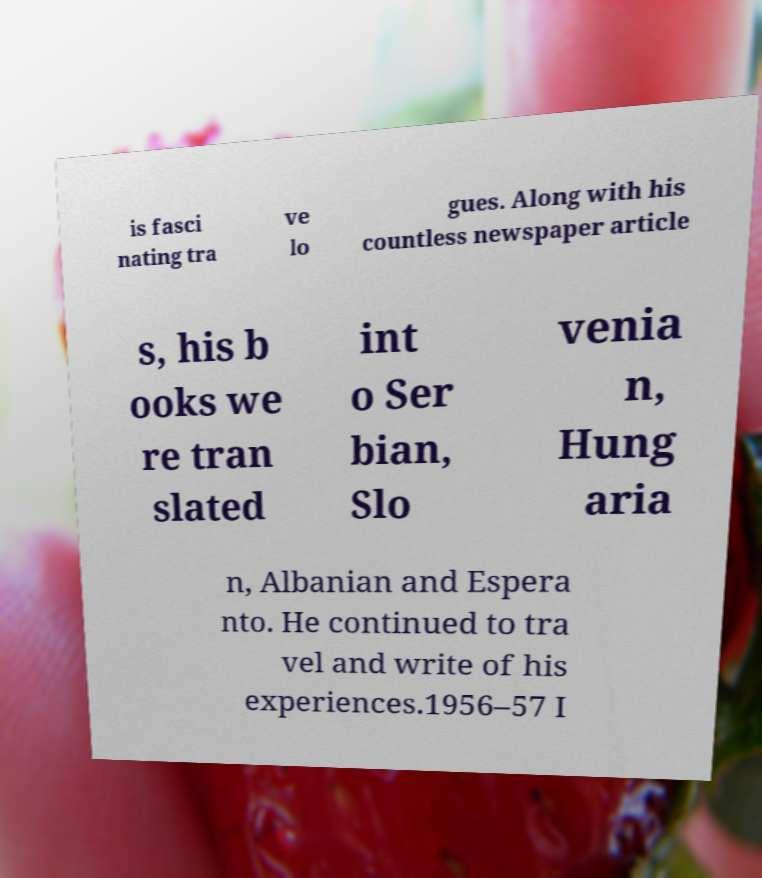For documentation purposes, I need the text within this image transcribed. Could you provide that? is fasci nating tra ve lo gues. Along with his countless newspaper article s, his b ooks we re tran slated int o Ser bian, Slo venia n, Hung aria n, Albanian and Espera nto. He continued to tra vel and write of his experiences.1956–57 I 